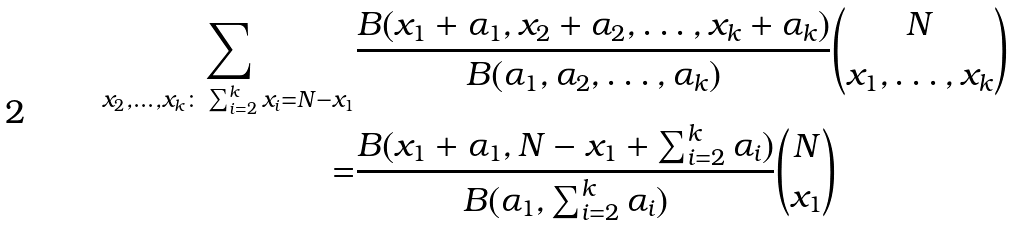Convert formula to latex. <formula><loc_0><loc_0><loc_500><loc_500>\sum _ { x _ { 2 } , \dots , x _ { k } \colon \sum _ { i = 2 } ^ { k } x _ { i } = N - x _ { 1 } } & \frac { B ( x _ { 1 } + \alpha _ { 1 } , x _ { 2 } + \alpha _ { 2 } , \dots , x _ { k } + \alpha _ { k } ) } { B ( \alpha _ { 1 } , \alpha _ { 2 } , \dots , \alpha _ { k } ) } { \binom { N } { x _ { 1 } , \dots , x _ { k } } } \\ = & \frac { B ( x _ { 1 } + \alpha _ { 1 } , N - x _ { 1 } + \sum _ { i = 2 } ^ { k } \alpha _ { i } ) } { B ( \alpha _ { 1 } , \sum _ { i = 2 } ^ { k } \alpha _ { i } ) } { \binom { N } { x _ { 1 } } }</formula> 